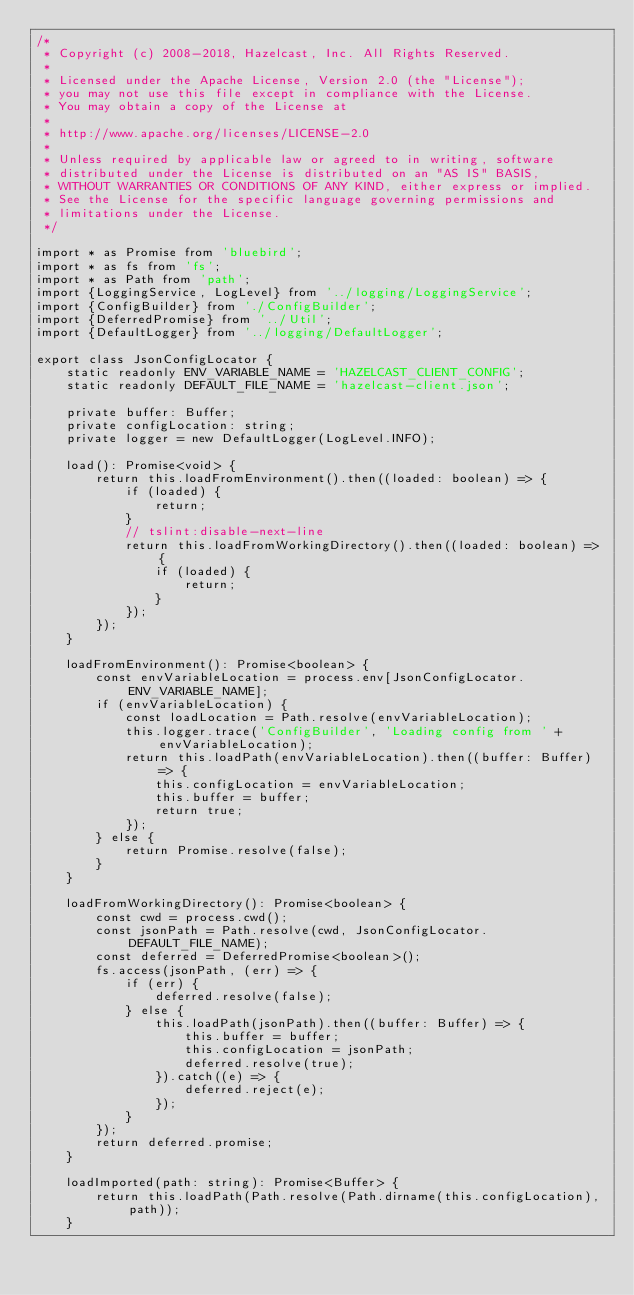Convert code to text. <code><loc_0><loc_0><loc_500><loc_500><_TypeScript_>/*
 * Copyright (c) 2008-2018, Hazelcast, Inc. All Rights Reserved.
 *
 * Licensed under the Apache License, Version 2.0 (the "License");
 * you may not use this file except in compliance with the License.
 * You may obtain a copy of the License at
 *
 * http://www.apache.org/licenses/LICENSE-2.0
 *
 * Unless required by applicable law or agreed to in writing, software
 * distributed under the License is distributed on an "AS IS" BASIS,
 * WITHOUT WARRANTIES OR CONDITIONS OF ANY KIND, either express or implied.
 * See the License for the specific language governing permissions and
 * limitations under the License.
 */

import * as Promise from 'bluebird';
import * as fs from 'fs';
import * as Path from 'path';
import {LoggingService, LogLevel} from '../logging/LoggingService';
import {ConfigBuilder} from './ConfigBuilder';
import {DeferredPromise} from '../Util';
import {DefaultLogger} from '../logging/DefaultLogger';

export class JsonConfigLocator {
    static readonly ENV_VARIABLE_NAME = 'HAZELCAST_CLIENT_CONFIG';
    static readonly DEFAULT_FILE_NAME = 'hazelcast-client.json';

    private buffer: Buffer;
    private configLocation: string;
    private logger = new DefaultLogger(LogLevel.INFO);

    load(): Promise<void> {
        return this.loadFromEnvironment().then((loaded: boolean) => {
            if (loaded) {
                return;
            }
            // tslint:disable-next-line
            return this.loadFromWorkingDirectory().then((loaded: boolean) => {
                if (loaded) {
                    return;
                }
            });
        });
    }

    loadFromEnvironment(): Promise<boolean> {
        const envVariableLocation = process.env[JsonConfigLocator.ENV_VARIABLE_NAME];
        if (envVariableLocation) {
            const loadLocation = Path.resolve(envVariableLocation);
            this.logger.trace('ConfigBuilder', 'Loading config from ' + envVariableLocation);
            return this.loadPath(envVariableLocation).then((buffer: Buffer) => {
                this.configLocation = envVariableLocation;
                this.buffer = buffer;
                return true;
            });
        } else {
            return Promise.resolve(false);
        }
    }

    loadFromWorkingDirectory(): Promise<boolean> {
        const cwd = process.cwd();
        const jsonPath = Path.resolve(cwd, JsonConfigLocator.DEFAULT_FILE_NAME);
        const deferred = DeferredPromise<boolean>();
        fs.access(jsonPath, (err) => {
            if (err) {
                deferred.resolve(false);
            } else {
                this.loadPath(jsonPath).then((buffer: Buffer) => {
                    this.buffer = buffer;
                    this.configLocation = jsonPath;
                    deferred.resolve(true);
                }).catch((e) => {
                    deferred.reject(e);
                });
            }
        });
        return deferred.promise;
    }

    loadImported(path: string): Promise<Buffer> {
        return this.loadPath(Path.resolve(Path.dirname(this.configLocation), path));
    }
</code> 